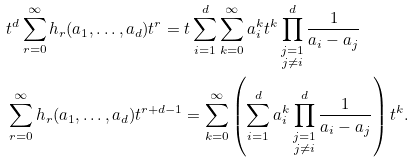<formula> <loc_0><loc_0><loc_500><loc_500>& t ^ { d } \sum _ { r = 0 } ^ { \infty } h _ { r } ( a _ { 1 } , \dots , a _ { d } ) t ^ { r } = t \sum _ { i = 1 } ^ { d } \sum _ { k = 0 } ^ { \infty } a _ { i } ^ { k } t ^ { k } \prod ^ { d } _ { \substack { j = 1 \\ j \neq i } } \frac { 1 } { a _ { i } - a _ { j } } \\ & \sum _ { r = 0 } ^ { \infty } h _ { r } ( a _ { 1 } , \dots , a _ { d } ) t ^ { r + d - 1 } = \sum _ { k = 0 } ^ { \infty } \left ( \sum _ { i = 1 } ^ { d } a _ { i } ^ { k } \prod ^ { d } _ { \substack { j = 1 \\ j \neq i } } \frac { 1 } { a _ { i } - a _ { j } } \right ) t ^ { k } .</formula> 